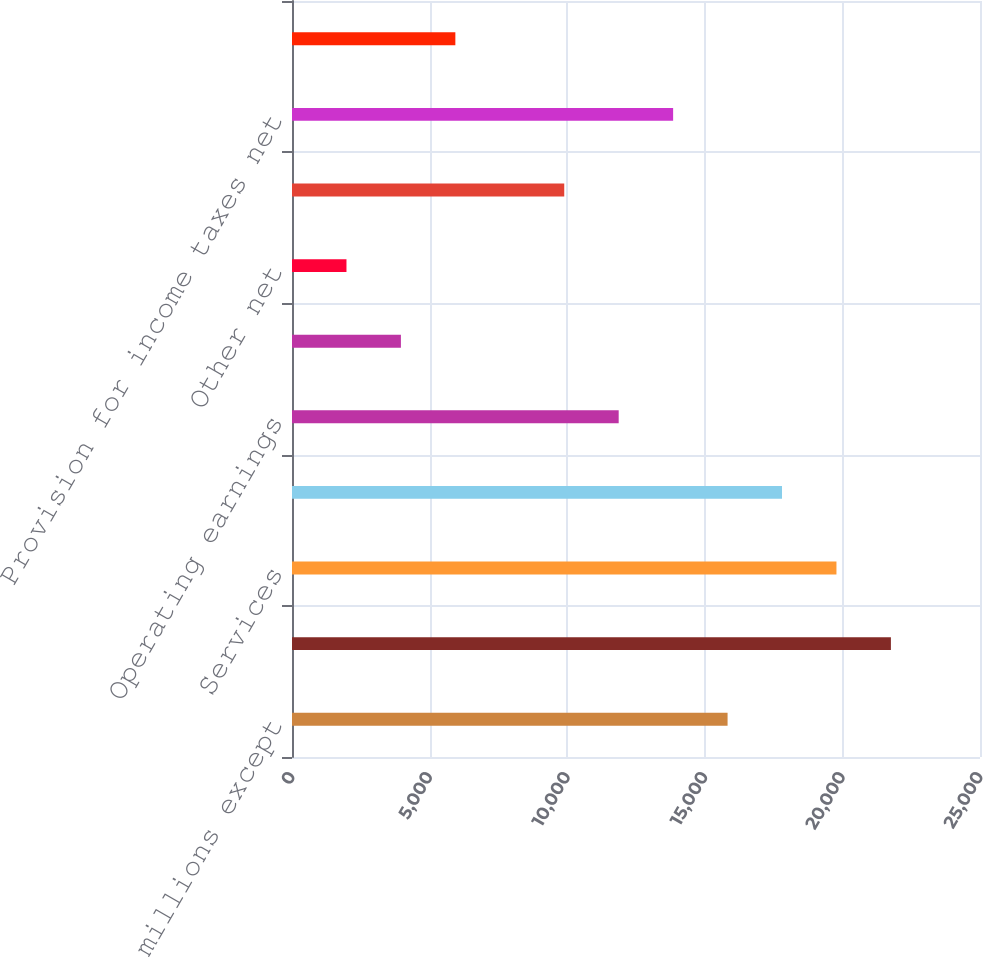<chart> <loc_0><loc_0><loc_500><loc_500><bar_chart><fcel>(Dollars in millions except<fcel>Products<fcel>Services<fcel>General and administrative<fcel>Operating earnings<fcel>Interest net<fcel>Other net<fcel>Earnings from continuing<fcel>Provision for income taxes net<fcel>Earnings (loss) from<nl><fcel>15827.4<fcel>21762.3<fcel>19784<fcel>17805.7<fcel>11870.8<fcel>3957.56<fcel>1979.25<fcel>9892.49<fcel>13849.1<fcel>5935.87<nl></chart> 